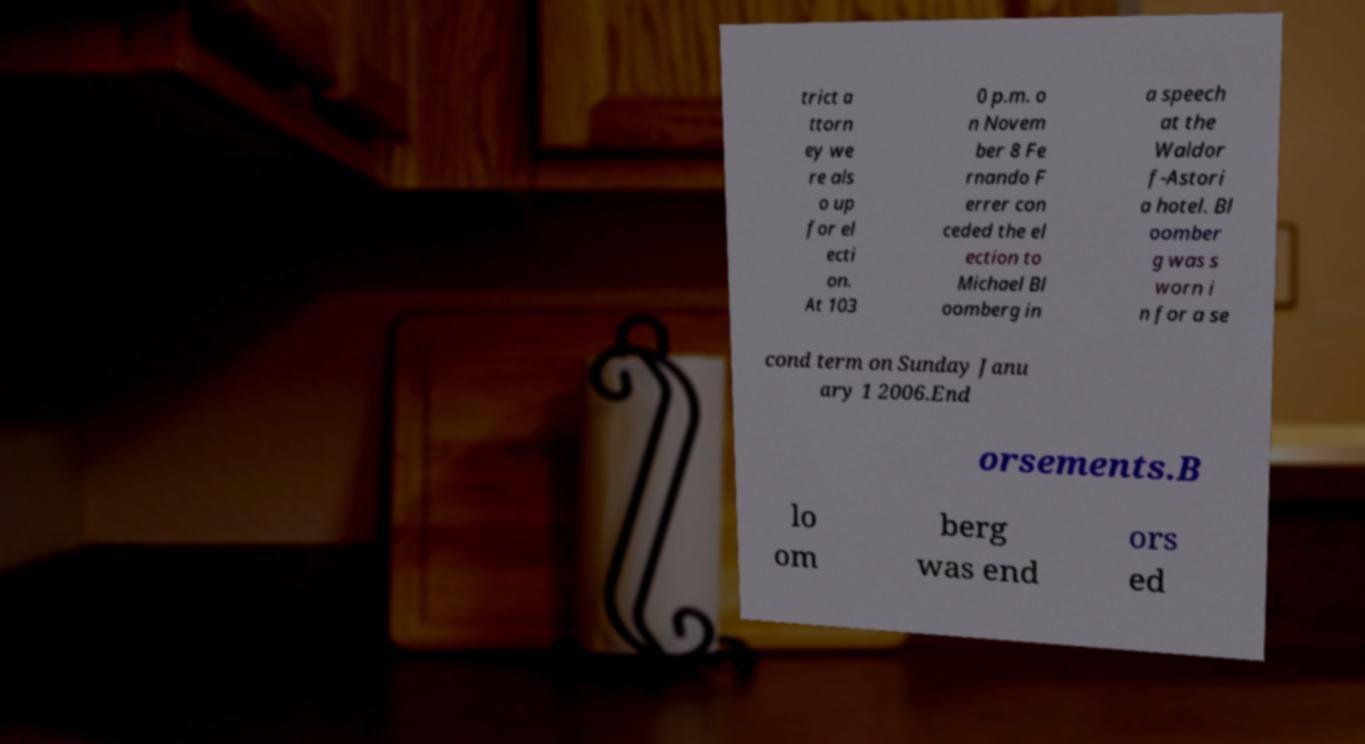Could you extract and type out the text from this image? trict a ttorn ey we re als o up for el ecti on. At 103 0 p.m. o n Novem ber 8 Fe rnando F errer con ceded the el ection to Michael Bl oomberg in a speech at the Waldor f-Astori a hotel. Bl oomber g was s worn i n for a se cond term on Sunday Janu ary 1 2006.End orsements.B lo om berg was end ors ed 